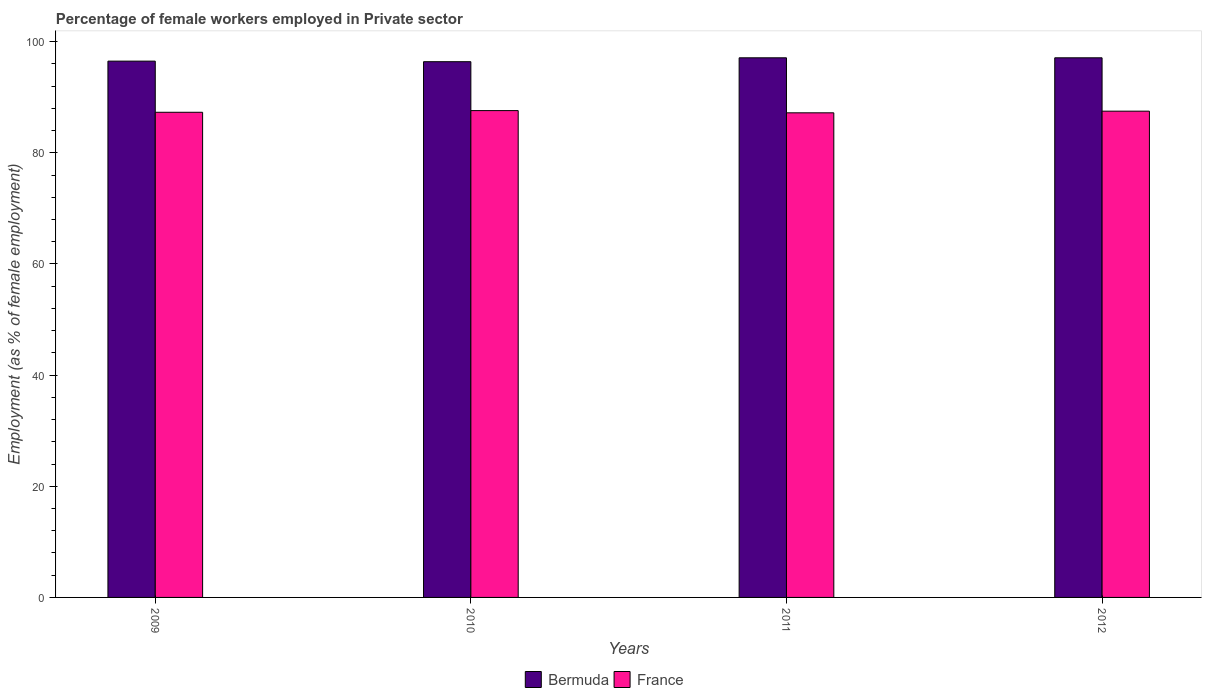Are the number of bars on each tick of the X-axis equal?
Make the answer very short. Yes. How many bars are there on the 2nd tick from the right?
Offer a very short reply. 2. In how many cases, is the number of bars for a given year not equal to the number of legend labels?
Give a very brief answer. 0. What is the percentage of females employed in Private sector in Bermuda in 2011?
Your response must be concise. 97.1. Across all years, what is the maximum percentage of females employed in Private sector in Bermuda?
Provide a succinct answer. 97.1. Across all years, what is the minimum percentage of females employed in Private sector in Bermuda?
Your answer should be very brief. 96.4. In which year was the percentage of females employed in Private sector in Bermuda minimum?
Ensure brevity in your answer.  2010. What is the total percentage of females employed in Private sector in Bermuda in the graph?
Keep it short and to the point. 387.1. What is the difference between the percentage of females employed in Private sector in Bermuda in 2011 and that in 2012?
Your answer should be compact. 0. What is the difference between the percentage of females employed in Private sector in France in 2011 and the percentage of females employed in Private sector in Bermuda in 2010?
Offer a terse response. -9.2. What is the average percentage of females employed in Private sector in Bermuda per year?
Your response must be concise. 96.77. In the year 2010, what is the difference between the percentage of females employed in Private sector in Bermuda and percentage of females employed in Private sector in France?
Give a very brief answer. 8.8. In how many years, is the percentage of females employed in Private sector in Bermuda greater than 84 %?
Your answer should be compact. 4. What is the ratio of the percentage of females employed in Private sector in France in 2009 to that in 2010?
Keep it short and to the point. 1. Is the percentage of females employed in Private sector in France in 2009 less than that in 2012?
Provide a succinct answer. Yes. Is the difference between the percentage of females employed in Private sector in Bermuda in 2010 and 2012 greater than the difference between the percentage of females employed in Private sector in France in 2010 and 2012?
Make the answer very short. No. What is the difference between the highest and the second highest percentage of females employed in Private sector in France?
Ensure brevity in your answer.  0.1. What is the difference between the highest and the lowest percentage of females employed in Private sector in France?
Your response must be concise. 0.4. What does the 1st bar from the left in 2011 represents?
Make the answer very short. Bermuda. What does the 2nd bar from the right in 2011 represents?
Offer a very short reply. Bermuda. How many bars are there?
Provide a succinct answer. 8. How many years are there in the graph?
Your response must be concise. 4. Are the values on the major ticks of Y-axis written in scientific E-notation?
Your response must be concise. No. Where does the legend appear in the graph?
Offer a terse response. Bottom center. What is the title of the graph?
Your response must be concise. Percentage of female workers employed in Private sector. Does "Sri Lanka" appear as one of the legend labels in the graph?
Keep it short and to the point. No. What is the label or title of the Y-axis?
Provide a succinct answer. Employment (as % of female employment). What is the Employment (as % of female employment) in Bermuda in 2009?
Offer a terse response. 96.5. What is the Employment (as % of female employment) of France in 2009?
Give a very brief answer. 87.3. What is the Employment (as % of female employment) of Bermuda in 2010?
Offer a terse response. 96.4. What is the Employment (as % of female employment) of France in 2010?
Offer a terse response. 87.6. What is the Employment (as % of female employment) in Bermuda in 2011?
Your answer should be compact. 97.1. What is the Employment (as % of female employment) in France in 2011?
Your answer should be very brief. 87.2. What is the Employment (as % of female employment) in Bermuda in 2012?
Offer a terse response. 97.1. What is the Employment (as % of female employment) of France in 2012?
Offer a terse response. 87.5. Across all years, what is the maximum Employment (as % of female employment) in Bermuda?
Make the answer very short. 97.1. Across all years, what is the maximum Employment (as % of female employment) of France?
Your response must be concise. 87.6. Across all years, what is the minimum Employment (as % of female employment) in Bermuda?
Your answer should be very brief. 96.4. Across all years, what is the minimum Employment (as % of female employment) in France?
Make the answer very short. 87.2. What is the total Employment (as % of female employment) in Bermuda in the graph?
Give a very brief answer. 387.1. What is the total Employment (as % of female employment) in France in the graph?
Provide a short and direct response. 349.6. What is the difference between the Employment (as % of female employment) of Bermuda in 2010 and that in 2011?
Make the answer very short. -0.7. What is the difference between the Employment (as % of female employment) of Bermuda in 2010 and that in 2012?
Your response must be concise. -0.7. What is the difference between the Employment (as % of female employment) in France in 2010 and that in 2012?
Your answer should be compact. 0.1. What is the difference between the Employment (as % of female employment) in Bermuda in 2011 and that in 2012?
Ensure brevity in your answer.  0. What is the difference between the Employment (as % of female employment) of France in 2011 and that in 2012?
Your answer should be compact. -0.3. What is the difference between the Employment (as % of female employment) of Bermuda in 2009 and the Employment (as % of female employment) of France in 2010?
Provide a short and direct response. 8.9. What is the difference between the Employment (as % of female employment) in Bermuda in 2009 and the Employment (as % of female employment) in France in 2011?
Your answer should be compact. 9.3. What is the difference between the Employment (as % of female employment) of Bermuda in 2009 and the Employment (as % of female employment) of France in 2012?
Provide a short and direct response. 9. What is the average Employment (as % of female employment) of Bermuda per year?
Provide a succinct answer. 96.78. What is the average Employment (as % of female employment) of France per year?
Your response must be concise. 87.4. In the year 2010, what is the difference between the Employment (as % of female employment) of Bermuda and Employment (as % of female employment) of France?
Keep it short and to the point. 8.8. In the year 2011, what is the difference between the Employment (as % of female employment) in Bermuda and Employment (as % of female employment) in France?
Your response must be concise. 9.9. What is the ratio of the Employment (as % of female employment) in Bermuda in 2009 to that in 2010?
Make the answer very short. 1. What is the ratio of the Employment (as % of female employment) of Bermuda in 2009 to that in 2011?
Offer a very short reply. 0.99. What is the ratio of the Employment (as % of female employment) in Bermuda in 2009 to that in 2012?
Provide a succinct answer. 0.99. What is the ratio of the Employment (as % of female employment) of France in 2009 to that in 2012?
Your response must be concise. 1. What is the ratio of the Employment (as % of female employment) of Bermuda in 2011 to that in 2012?
Offer a terse response. 1. What is the difference between the highest and the second highest Employment (as % of female employment) of Bermuda?
Provide a short and direct response. 0. What is the difference between the highest and the second highest Employment (as % of female employment) of France?
Your answer should be compact. 0.1. What is the difference between the highest and the lowest Employment (as % of female employment) in France?
Offer a terse response. 0.4. 